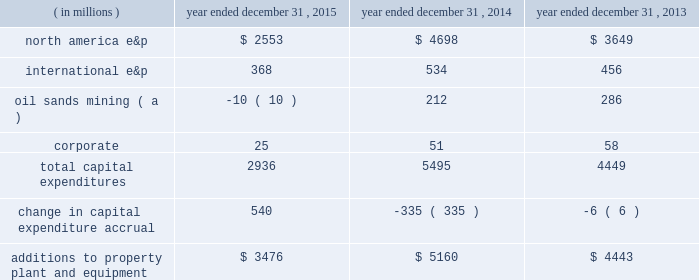Borrowings reflect net proceeds received from the issuance of senior notes in june 2015 .
See liquidity and capital resources below for additional information .
In november 2015 , we repaid our $ 1 billion 0.90% ( 0.90 % ) senior notes upon maturity .
In october 2015 , we announced an adjustment to our quarterly dividend .
See capital requirements below for additional information .
Additions to property , plant and equipment are our most significant use of cash and cash equivalents .
The table shows capital expenditures related to continuing operations by segment and reconciles to additions to property , plant and equipment as presented in the consolidated statements of cash flows for 2015 , 2014 and 2013: .
( a ) reflects reimbursements earned from the governments of canada and alberta related to funds previously expended for quest ccs capital equipment .
Quest ccs was successfully completed and commissioned in the fourth quarter of 2015 .
During 2014 , we acquired 29 million shares at a cost of $ 1 billion and in 2013 acquired 14 million shares at a cost of $ 500 million .
There were no share repurchases in 2015 .
See item 8 .
Financial statements and supplementary data 2013 note 23 to the consolidated financial statements for discussion of purchases of common stock .
Liquidity and capital resources on june 10 , 2015 , we issued $ 2 billion aggregate principal amount of unsecured senior notes which consist of the following series : 2022 $ 600 million of 2.70% ( 2.70 % ) senior notes due june 1 , 2020 2022 $ 900 million of 3.85% ( 3.85 % ) senior notes due june 1 , 2025 2022 $ 500 million of 5.20% ( 5.20 % ) senior notes due june 1 , 2045 interest on each series of senior notes is payable semi-annually beginning december 1 , 2015 .
We used the aggregate net proceeds to repay our $ 1 billion 0.90% ( 0.90 % ) senior notes on november 2 , 2015 , and the remainder for general corporate purposes .
In may 2015 , we amended our $ 2.5 billion credit facility to increase the facility size by $ 500 million to a total of $ 3.0 billion and extend the maturity date by an additional year such that the credit facility now matures in may 2020 .
The amendment additionally provides us the ability to request two one-year extensions to the maturity date and an option to increase the commitment amount by up to an additional $ 500 million , subject to the consent of any increasing lenders .
The sub-facilities for swing-line loans and letters of credit remain unchanged allowing up to an aggregate amount of $ 100 million and $ 500 million , respectively .
Fees on the unused commitment of each lender , as well as the borrowing options under the credit facility , remain unchanged .
Our main sources of liquidity are cash and cash equivalents , internally generated cash flow from operations , capital market transactions , our committed revolving credit facility and sales of non-core assets .
Our working capital requirements are supported by these sources and we may issue either commercial paper backed by our $ 3.0 billion revolving credit facility or draw on our $ 3.0 billion revolving credit facility to meet short-term cash requirements or issue debt or equity securities through the shelf registration statement discussed below as part of our longer-term liquidity and capital management .
Because of the alternatives available to us as discussed above , we believe that our short-term and long-term liquidity is adequate to fund not only our current operations , but also our near-term and long-term funding requirements including our capital spending programs , dividend payments , defined benefit plan contributions , repayment of debt maturities and other amounts that may ultimately be paid in connection with contingencies .
General economic conditions , commodity prices , and financial , business and other factors could affect our operations and our ability to access the capital markets .
A downgrade in our credit ratings could negatively impact our cost of capital and our ability to access the capital markets , increase the interest rate and fees we pay on our unsecured revolving credit facility , restrict our access to the commercial paper market , or require us to post letters of credit or other forms of collateral for certain .
What percentage of total capital expenditures in 2016 were related to north america e&p? 
Computations: (2553 / 2936)
Answer: 0.86955. 